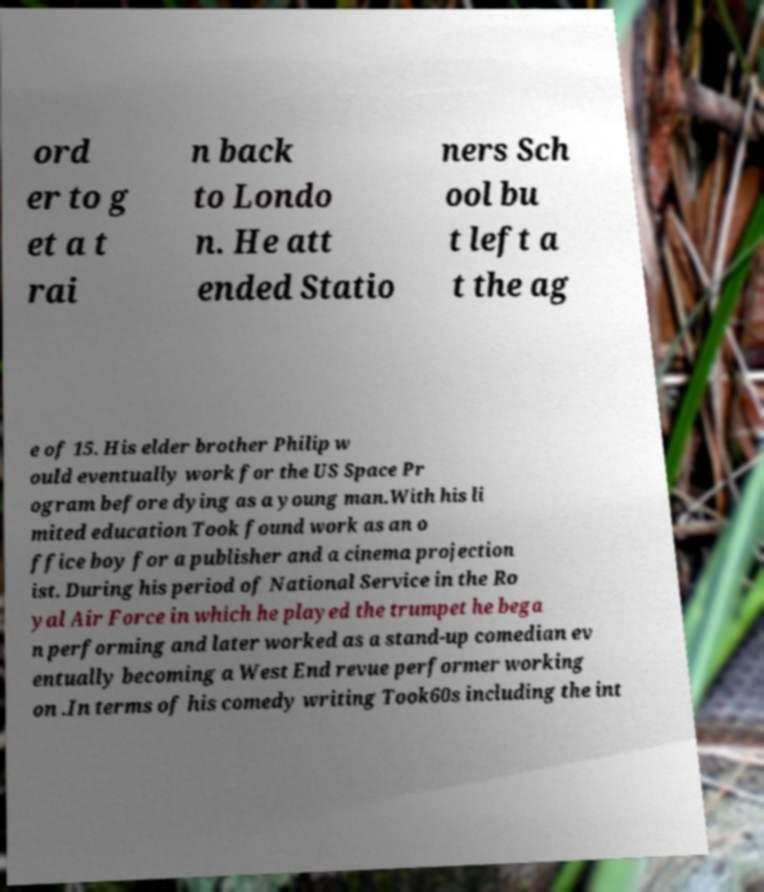Can you accurately transcribe the text from the provided image for me? ord er to g et a t rai n back to Londo n. He att ended Statio ners Sch ool bu t left a t the ag e of 15. His elder brother Philip w ould eventually work for the US Space Pr ogram before dying as a young man.With his li mited education Took found work as an o ffice boy for a publisher and a cinema projection ist. During his period of National Service in the Ro yal Air Force in which he played the trumpet he bega n performing and later worked as a stand-up comedian ev entually becoming a West End revue performer working on .In terms of his comedy writing Took60s including the int 